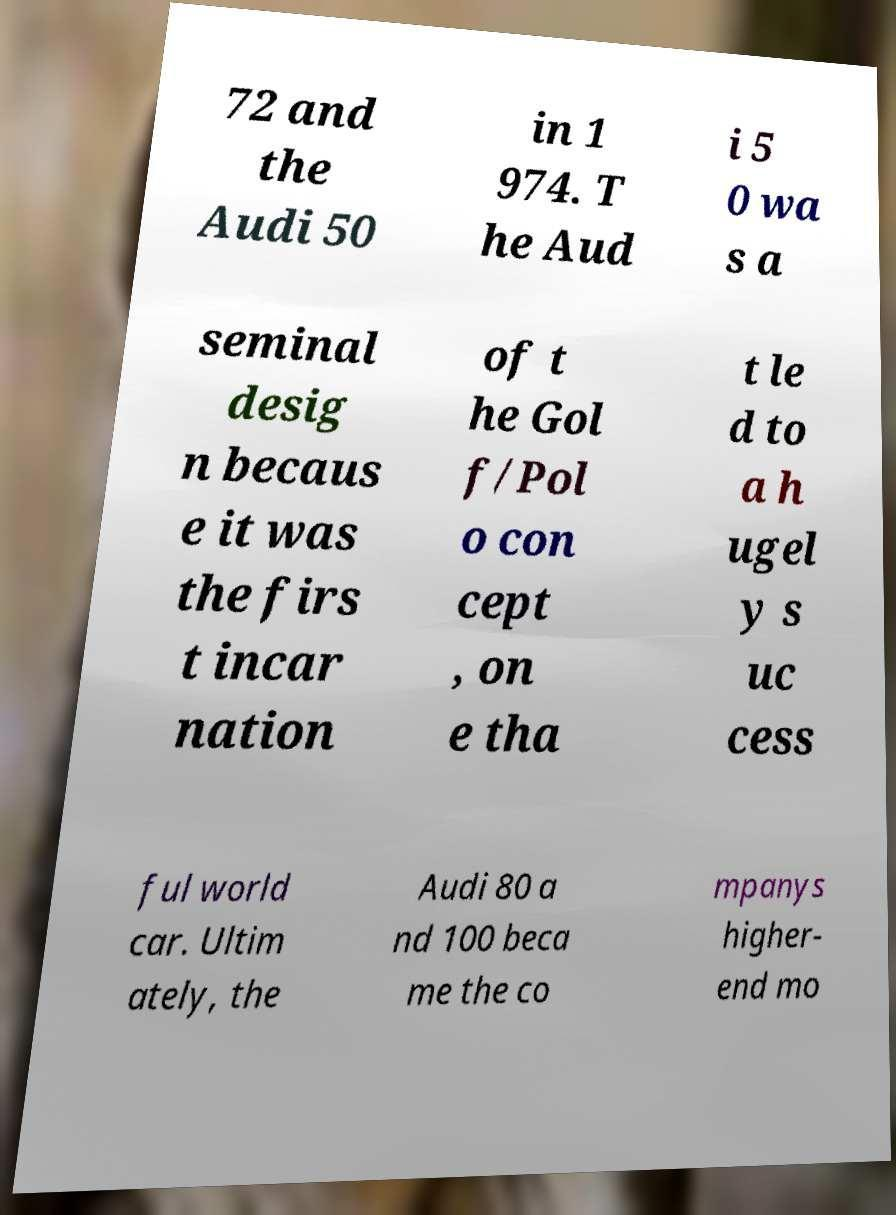Can you accurately transcribe the text from the provided image for me? 72 and the Audi 50 in 1 974. T he Aud i 5 0 wa s a seminal desig n becaus e it was the firs t incar nation of t he Gol f/Pol o con cept , on e tha t le d to a h ugel y s uc cess ful world car. Ultim ately, the Audi 80 a nd 100 beca me the co mpanys higher- end mo 